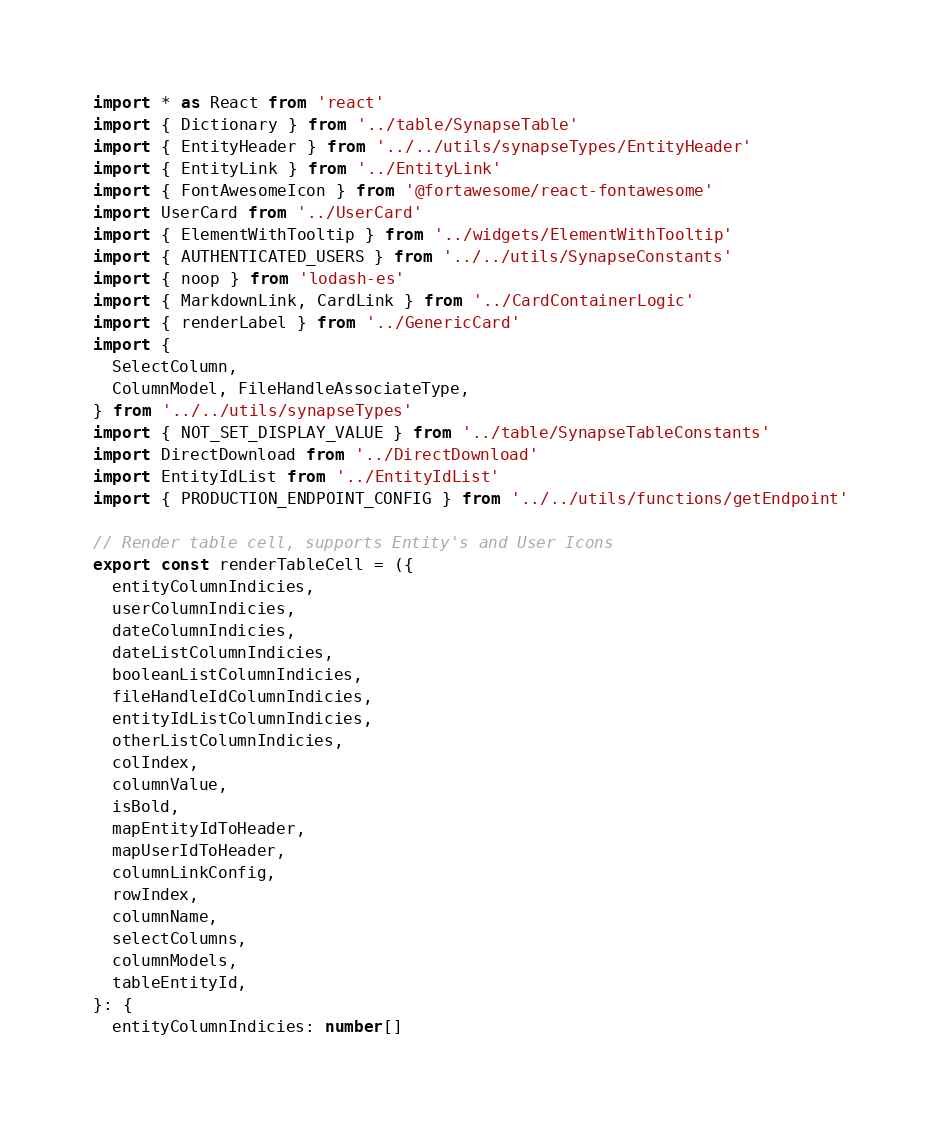<code> <loc_0><loc_0><loc_500><loc_500><_TypeScript_>import * as React from 'react'
import { Dictionary } from '../table/SynapseTable'
import { EntityHeader } from '../../utils/synapseTypes/EntityHeader'
import { EntityLink } from '../EntityLink'
import { FontAwesomeIcon } from '@fortawesome/react-fontawesome'
import UserCard from '../UserCard'
import { ElementWithTooltip } from '../widgets/ElementWithTooltip'
import { AUTHENTICATED_USERS } from '../../utils/SynapseConstants'
import { noop } from 'lodash-es'
import { MarkdownLink, CardLink } from '../CardContainerLogic'
import { renderLabel } from '../GenericCard'
import {
  SelectColumn,
  ColumnModel, FileHandleAssociateType,
} from '../../utils/synapseTypes'
import { NOT_SET_DISPLAY_VALUE } from '../table/SynapseTableConstants'
import DirectDownload from '../DirectDownload'
import EntityIdList from '../EntityIdList'
import { PRODUCTION_ENDPOINT_CONFIG } from '../../utils/functions/getEndpoint'

// Render table cell, supports Entity's and User Icons
export const renderTableCell = ({
  entityColumnIndicies,
  userColumnIndicies,
  dateColumnIndicies,
  dateListColumnIndicies,
  booleanListColumnIndicies,
  fileHandleIdColumnIndicies,
  entityIdListColumnIndicies,
  otherListColumnIndicies,
  colIndex,
  columnValue,
  isBold,
  mapEntityIdToHeader,
  mapUserIdToHeader,
  columnLinkConfig,
  rowIndex,
  columnName,
  selectColumns,
  columnModels,
  tableEntityId,
}: {
  entityColumnIndicies: number[]</code> 